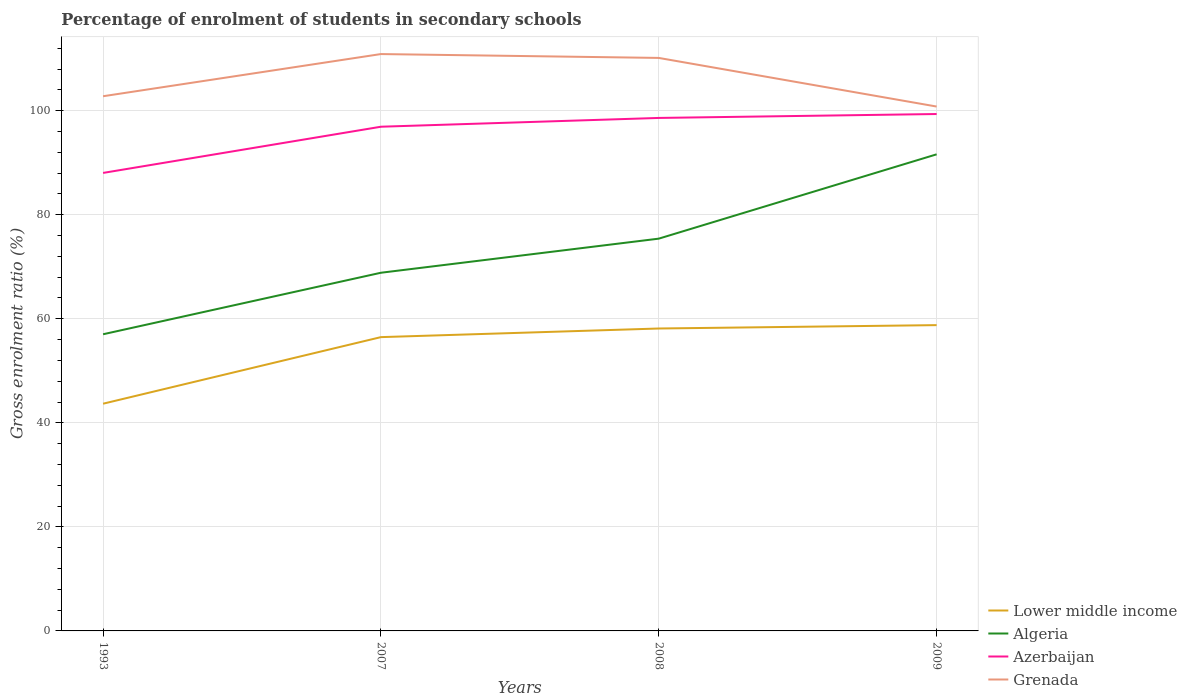Across all years, what is the maximum percentage of students enrolled in secondary schools in Azerbaijan?
Provide a short and direct response. 88.04. What is the total percentage of students enrolled in secondary schools in Algeria in the graph?
Your answer should be compact. -18.38. What is the difference between the highest and the second highest percentage of students enrolled in secondary schools in Azerbaijan?
Provide a succinct answer. 11.32. What is the difference between the highest and the lowest percentage of students enrolled in secondary schools in Algeria?
Provide a short and direct response. 2. How many years are there in the graph?
Your response must be concise. 4. How many legend labels are there?
Your response must be concise. 4. What is the title of the graph?
Ensure brevity in your answer.  Percentage of enrolment of students in secondary schools. What is the label or title of the X-axis?
Your answer should be compact. Years. What is the Gross enrolment ratio (%) in Lower middle income in 1993?
Ensure brevity in your answer.  43.68. What is the Gross enrolment ratio (%) of Algeria in 1993?
Provide a succinct answer. 57.02. What is the Gross enrolment ratio (%) in Azerbaijan in 1993?
Your answer should be very brief. 88.04. What is the Gross enrolment ratio (%) of Grenada in 1993?
Offer a very short reply. 102.78. What is the Gross enrolment ratio (%) in Lower middle income in 2007?
Offer a very short reply. 56.47. What is the Gross enrolment ratio (%) of Algeria in 2007?
Provide a succinct answer. 68.85. What is the Gross enrolment ratio (%) of Azerbaijan in 2007?
Your answer should be compact. 96.92. What is the Gross enrolment ratio (%) in Grenada in 2007?
Give a very brief answer. 110.88. What is the Gross enrolment ratio (%) in Lower middle income in 2008?
Your answer should be compact. 58.13. What is the Gross enrolment ratio (%) of Algeria in 2008?
Offer a very short reply. 75.4. What is the Gross enrolment ratio (%) in Azerbaijan in 2008?
Make the answer very short. 98.61. What is the Gross enrolment ratio (%) in Grenada in 2008?
Offer a terse response. 110.14. What is the Gross enrolment ratio (%) in Lower middle income in 2009?
Provide a short and direct response. 58.78. What is the Gross enrolment ratio (%) of Algeria in 2009?
Your answer should be very brief. 91.61. What is the Gross enrolment ratio (%) in Azerbaijan in 2009?
Give a very brief answer. 99.36. What is the Gross enrolment ratio (%) in Grenada in 2009?
Keep it short and to the point. 100.79. Across all years, what is the maximum Gross enrolment ratio (%) in Lower middle income?
Ensure brevity in your answer.  58.78. Across all years, what is the maximum Gross enrolment ratio (%) of Algeria?
Your answer should be very brief. 91.61. Across all years, what is the maximum Gross enrolment ratio (%) of Azerbaijan?
Your answer should be compact. 99.36. Across all years, what is the maximum Gross enrolment ratio (%) in Grenada?
Offer a terse response. 110.88. Across all years, what is the minimum Gross enrolment ratio (%) in Lower middle income?
Give a very brief answer. 43.68. Across all years, what is the minimum Gross enrolment ratio (%) of Algeria?
Provide a short and direct response. 57.02. Across all years, what is the minimum Gross enrolment ratio (%) of Azerbaijan?
Make the answer very short. 88.04. Across all years, what is the minimum Gross enrolment ratio (%) of Grenada?
Your answer should be very brief. 100.79. What is the total Gross enrolment ratio (%) of Lower middle income in the graph?
Your answer should be very brief. 217.06. What is the total Gross enrolment ratio (%) in Algeria in the graph?
Keep it short and to the point. 292.89. What is the total Gross enrolment ratio (%) of Azerbaijan in the graph?
Offer a terse response. 382.92. What is the total Gross enrolment ratio (%) in Grenada in the graph?
Make the answer very short. 424.6. What is the difference between the Gross enrolment ratio (%) of Lower middle income in 1993 and that in 2007?
Offer a terse response. -12.8. What is the difference between the Gross enrolment ratio (%) of Algeria in 1993 and that in 2007?
Provide a succinct answer. -11.83. What is the difference between the Gross enrolment ratio (%) in Azerbaijan in 1993 and that in 2007?
Keep it short and to the point. -8.88. What is the difference between the Gross enrolment ratio (%) in Grenada in 1993 and that in 2007?
Your response must be concise. -8.11. What is the difference between the Gross enrolment ratio (%) of Lower middle income in 1993 and that in 2008?
Offer a very short reply. -14.46. What is the difference between the Gross enrolment ratio (%) of Algeria in 1993 and that in 2008?
Your answer should be compact. -18.38. What is the difference between the Gross enrolment ratio (%) in Azerbaijan in 1993 and that in 2008?
Your response must be concise. -10.57. What is the difference between the Gross enrolment ratio (%) in Grenada in 1993 and that in 2008?
Your response must be concise. -7.36. What is the difference between the Gross enrolment ratio (%) in Lower middle income in 1993 and that in 2009?
Make the answer very short. -15.1. What is the difference between the Gross enrolment ratio (%) of Algeria in 1993 and that in 2009?
Provide a short and direct response. -34.59. What is the difference between the Gross enrolment ratio (%) of Azerbaijan in 1993 and that in 2009?
Your response must be concise. -11.32. What is the difference between the Gross enrolment ratio (%) in Grenada in 1993 and that in 2009?
Your answer should be very brief. 1.98. What is the difference between the Gross enrolment ratio (%) in Lower middle income in 2007 and that in 2008?
Your response must be concise. -1.66. What is the difference between the Gross enrolment ratio (%) of Algeria in 2007 and that in 2008?
Keep it short and to the point. -6.55. What is the difference between the Gross enrolment ratio (%) of Azerbaijan in 2007 and that in 2008?
Offer a very short reply. -1.69. What is the difference between the Gross enrolment ratio (%) in Grenada in 2007 and that in 2008?
Keep it short and to the point. 0.74. What is the difference between the Gross enrolment ratio (%) in Lower middle income in 2007 and that in 2009?
Offer a terse response. -2.31. What is the difference between the Gross enrolment ratio (%) of Algeria in 2007 and that in 2009?
Your answer should be compact. -22.76. What is the difference between the Gross enrolment ratio (%) of Azerbaijan in 2007 and that in 2009?
Ensure brevity in your answer.  -2.44. What is the difference between the Gross enrolment ratio (%) of Grenada in 2007 and that in 2009?
Your answer should be compact. 10.09. What is the difference between the Gross enrolment ratio (%) of Lower middle income in 2008 and that in 2009?
Provide a succinct answer. -0.65. What is the difference between the Gross enrolment ratio (%) in Algeria in 2008 and that in 2009?
Ensure brevity in your answer.  -16.21. What is the difference between the Gross enrolment ratio (%) in Azerbaijan in 2008 and that in 2009?
Give a very brief answer. -0.75. What is the difference between the Gross enrolment ratio (%) in Grenada in 2008 and that in 2009?
Offer a very short reply. 9.35. What is the difference between the Gross enrolment ratio (%) of Lower middle income in 1993 and the Gross enrolment ratio (%) of Algeria in 2007?
Provide a succinct answer. -25.18. What is the difference between the Gross enrolment ratio (%) of Lower middle income in 1993 and the Gross enrolment ratio (%) of Azerbaijan in 2007?
Provide a short and direct response. -53.24. What is the difference between the Gross enrolment ratio (%) in Lower middle income in 1993 and the Gross enrolment ratio (%) in Grenada in 2007?
Offer a terse response. -67.21. What is the difference between the Gross enrolment ratio (%) in Algeria in 1993 and the Gross enrolment ratio (%) in Azerbaijan in 2007?
Give a very brief answer. -39.89. What is the difference between the Gross enrolment ratio (%) in Algeria in 1993 and the Gross enrolment ratio (%) in Grenada in 2007?
Your answer should be compact. -53.86. What is the difference between the Gross enrolment ratio (%) of Azerbaijan in 1993 and the Gross enrolment ratio (%) of Grenada in 2007?
Provide a short and direct response. -22.85. What is the difference between the Gross enrolment ratio (%) in Lower middle income in 1993 and the Gross enrolment ratio (%) in Algeria in 2008?
Provide a succinct answer. -31.73. What is the difference between the Gross enrolment ratio (%) in Lower middle income in 1993 and the Gross enrolment ratio (%) in Azerbaijan in 2008?
Your response must be concise. -54.93. What is the difference between the Gross enrolment ratio (%) of Lower middle income in 1993 and the Gross enrolment ratio (%) of Grenada in 2008?
Keep it short and to the point. -66.47. What is the difference between the Gross enrolment ratio (%) in Algeria in 1993 and the Gross enrolment ratio (%) in Azerbaijan in 2008?
Provide a succinct answer. -41.58. What is the difference between the Gross enrolment ratio (%) in Algeria in 1993 and the Gross enrolment ratio (%) in Grenada in 2008?
Ensure brevity in your answer.  -53.12. What is the difference between the Gross enrolment ratio (%) in Azerbaijan in 1993 and the Gross enrolment ratio (%) in Grenada in 2008?
Your answer should be very brief. -22.1. What is the difference between the Gross enrolment ratio (%) in Lower middle income in 1993 and the Gross enrolment ratio (%) in Algeria in 2009?
Keep it short and to the point. -47.94. What is the difference between the Gross enrolment ratio (%) of Lower middle income in 1993 and the Gross enrolment ratio (%) of Azerbaijan in 2009?
Keep it short and to the point. -55.68. What is the difference between the Gross enrolment ratio (%) of Lower middle income in 1993 and the Gross enrolment ratio (%) of Grenada in 2009?
Offer a very short reply. -57.12. What is the difference between the Gross enrolment ratio (%) of Algeria in 1993 and the Gross enrolment ratio (%) of Azerbaijan in 2009?
Your response must be concise. -42.33. What is the difference between the Gross enrolment ratio (%) in Algeria in 1993 and the Gross enrolment ratio (%) in Grenada in 2009?
Your response must be concise. -43.77. What is the difference between the Gross enrolment ratio (%) of Azerbaijan in 1993 and the Gross enrolment ratio (%) of Grenada in 2009?
Ensure brevity in your answer.  -12.76. What is the difference between the Gross enrolment ratio (%) of Lower middle income in 2007 and the Gross enrolment ratio (%) of Algeria in 2008?
Offer a terse response. -18.93. What is the difference between the Gross enrolment ratio (%) in Lower middle income in 2007 and the Gross enrolment ratio (%) in Azerbaijan in 2008?
Your answer should be very brief. -42.13. What is the difference between the Gross enrolment ratio (%) in Lower middle income in 2007 and the Gross enrolment ratio (%) in Grenada in 2008?
Provide a short and direct response. -53.67. What is the difference between the Gross enrolment ratio (%) of Algeria in 2007 and the Gross enrolment ratio (%) of Azerbaijan in 2008?
Offer a very short reply. -29.75. What is the difference between the Gross enrolment ratio (%) of Algeria in 2007 and the Gross enrolment ratio (%) of Grenada in 2008?
Provide a short and direct response. -41.29. What is the difference between the Gross enrolment ratio (%) of Azerbaijan in 2007 and the Gross enrolment ratio (%) of Grenada in 2008?
Give a very brief answer. -13.22. What is the difference between the Gross enrolment ratio (%) of Lower middle income in 2007 and the Gross enrolment ratio (%) of Algeria in 2009?
Offer a terse response. -35.14. What is the difference between the Gross enrolment ratio (%) of Lower middle income in 2007 and the Gross enrolment ratio (%) of Azerbaijan in 2009?
Provide a succinct answer. -42.88. What is the difference between the Gross enrolment ratio (%) of Lower middle income in 2007 and the Gross enrolment ratio (%) of Grenada in 2009?
Provide a succinct answer. -44.32. What is the difference between the Gross enrolment ratio (%) of Algeria in 2007 and the Gross enrolment ratio (%) of Azerbaijan in 2009?
Provide a short and direct response. -30.51. What is the difference between the Gross enrolment ratio (%) in Algeria in 2007 and the Gross enrolment ratio (%) in Grenada in 2009?
Ensure brevity in your answer.  -31.94. What is the difference between the Gross enrolment ratio (%) of Azerbaijan in 2007 and the Gross enrolment ratio (%) of Grenada in 2009?
Ensure brevity in your answer.  -3.88. What is the difference between the Gross enrolment ratio (%) in Lower middle income in 2008 and the Gross enrolment ratio (%) in Algeria in 2009?
Ensure brevity in your answer.  -33.48. What is the difference between the Gross enrolment ratio (%) of Lower middle income in 2008 and the Gross enrolment ratio (%) of Azerbaijan in 2009?
Make the answer very short. -41.23. What is the difference between the Gross enrolment ratio (%) in Lower middle income in 2008 and the Gross enrolment ratio (%) in Grenada in 2009?
Provide a succinct answer. -42.66. What is the difference between the Gross enrolment ratio (%) of Algeria in 2008 and the Gross enrolment ratio (%) of Azerbaijan in 2009?
Your answer should be compact. -23.95. What is the difference between the Gross enrolment ratio (%) in Algeria in 2008 and the Gross enrolment ratio (%) in Grenada in 2009?
Provide a short and direct response. -25.39. What is the difference between the Gross enrolment ratio (%) of Azerbaijan in 2008 and the Gross enrolment ratio (%) of Grenada in 2009?
Make the answer very short. -2.19. What is the average Gross enrolment ratio (%) in Lower middle income per year?
Keep it short and to the point. 54.27. What is the average Gross enrolment ratio (%) of Algeria per year?
Your answer should be compact. 73.22. What is the average Gross enrolment ratio (%) of Azerbaijan per year?
Ensure brevity in your answer.  95.73. What is the average Gross enrolment ratio (%) in Grenada per year?
Offer a very short reply. 106.15. In the year 1993, what is the difference between the Gross enrolment ratio (%) in Lower middle income and Gross enrolment ratio (%) in Algeria?
Offer a terse response. -13.35. In the year 1993, what is the difference between the Gross enrolment ratio (%) in Lower middle income and Gross enrolment ratio (%) in Azerbaijan?
Offer a terse response. -44.36. In the year 1993, what is the difference between the Gross enrolment ratio (%) in Lower middle income and Gross enrolment ratio (%) in Grenada?
Give a very brief answer. -59.1. In the year 1993, what is the difference between the Gross enrolment ratio (%) of Algeria and Gross enrolment ratio (%) of Azerbaijan?
Your answer should be very brief. -31.01. In the year 1993, what is the difference between the Gross enrolment ratio (%) of Algeria and Gross enrolment ratio (%) of Grenada?
Offer a very short reply. -45.75. In the year 1993, what is the difference between the Gross enrolment ratio (%) in Azerbaijan and Gross enrolment ratio (%) in Grenada?
Your answer should be compact. -14.74. In the year 2007, what is the difference between the Gross enrolment ratio (%) of Lower middle income and Gross enrolment ratio (%) of Algeria?
Keep it short and to the point. -12.38. In the year 2007, what is the difference between the Gross enrolment ratio (%) of Lower middle income and Gross enrolment ratio (%) of Azerbaijan?
Give a very brief answer. -40.44. In the year 2007, what is the difference between the Gross enrolment ratio (%) of Lower middle income and Gross enrolment ratio (%) of Grenada?
Provide a short and direct response. -54.41. In the year 2007, what is the difference between the Gross enrolment ratio (%) of Algeria and Gross enrolment ratio (%) of Azerbaijan?
Your answer should be compact. -28.07. In the year 2007, what is the difference between the Gross enrolment ratio (%) of Algeria and Gross enrolment ratio (%) of Grenada?
Your answer should be compact. -42.03. In the year 2007, what is the difference between the Gross enrolment ratio (%) in Azerbaijan and Gross enrolment ratio (%) in Grenada?
Your answer should be very brief. -13.97. In the year 2008, what is the difference between the Gross enrolment ratio (%) in Lower middle income and Gross enrolment ratio (%) in Algeria?
Your answer should be very brief. -17.27. In the year 2008, what is the difference between the Gross enrolment ratio (%) in Lower middle income and Gross enrolment ratio (%) in Azerbaijan?
Your answer should be compact. -40.47. In the year 2008, what is the difference between the Gross enrolment ratio (%) of Lower middle income and Gross enrolment ratio (%) of Grenada?
Your response must be concise. -52.01. In the year 2008, what is the difference between the Gross enrolment ratio (%) in Algeria and Gross enrolment ratio (%) in Azerbaijan?
Provide a short and direct response. -23.2. In the year 2008, what is the difference between the Gross enrolment ratio (%) of Algeria and Gross enrolment ratio (%) of Grenada?
Your response must be concise. -34.74. In the year 2008, what is the difference between the Gross enrolment ratio (%) in Azerbaijan and Gross enrolment ratio (%) in Grenada?
Offer a very short reply. -11.54. In the year 2009, what is the difference between the Gross enrolment ratio (%) of Lower middle income and Gross enrolment ratio (%) of Algeria?
Offer a terse response. -32.83. In the year 2009, what is the difference between the Gross enrolment ratio (%) in Lower middle income and Gross enrolment ratio (%) in Azerbaijan?
Make the answer very short. -40.58. In the year 2009, what is the difference between the Gross enrolment ratio (%) in Lower middle income and Gross enrolment ratio (%) in Grenada?
Offer a very short reply. -42.01. In the year 2009, what is the difference between the Gross enrolment ratio (%) in Algeria and Gross enrolment ratio (%) in Azerbaijan?
Make the answer very short. -7.75. In the year 2009, what is the difference between the Gross enrolment ratio (%) in Algeria and Gross enrolment ratio (%) in Grenada?
Provide a succinct answer. -9.18. In the year 2009, what is the difference between the Gross enrolment ratio (%) in Azerbaijan and Gross enrolment ratio (%) in Grenada?
Your answer should be compact. -1.44. What is the ratio of the Gross enrolment ratio (%) in Lower middle income in 1993 to that in 2007?
Provide a short and direct response. 0.77. What is the ratio of the Gross enrolment ratio (%) of Algeria in 1993 to that in 2007?
Offer a terse response. 0.83. What is the ratio of the Gross enrolment ratio (%) of Azerbaijan in 1993 to that in 2007?
Your answer should be very brief. 0.91. What is the ratio of the Gross enrolment ratio (%) in Grenada in 1993 to that in 2007?
Offer a terse response. 0.93. What is the ratio of the Gross enrolment ratio (%) in Lower middle income in 1993 to that in 2008?
Provide a succinct answer. 0.75. What is the ratio of the Gross enrolment ratio (%) of Algeria in 1993 to that in 2008?
Your answer should be compact. 0.76. What is the ratio of the Gross enrolment ratio (%) of Azerbaijan in 1993 to that in 2008?
Your response must be concise. 0.89. What is the ratio of the Gross enrolment ratio (%) in Grenada in 1993 to that in 2008?
Your response must be concise. 0.93. What is the ratio of the Gross enrolment ratio (%) in Lower middle income in 1993 to that in 2009?
Offer a terse response. 0.74. What is the ratio of the Gross enrolment ratio (%) of Algeria in 1993 to that in 2009?
Your answer should be compact. 0.62. What is the ratio of the Gross enrolment ratio (%) in Azerbaijan in 1993 to that in 2009?
Your answer should be very brief. 0.89. What is the ratio of the Gross enrolment ratio (%) in Grenada in 1993 to that in 2009?
Give a very brief answer. 1.02. What is the ratio of the Gross enrolment ratio (%) of Lower middle income in 2007 to that in 2008?
Your answer should be compact. 0.97. What is the ratio of the Gross enrolment ratio (%) of Algeria in 2007 to that in 2008?
Make the answer very short. 0.91. What is the ratio of the Gross enrolment ratio (%) of Azerbaijan in 2007 to that in 2008?
Provide a short and direct response. 0.98. What is the ratio of the Gross enrolment ratio (%) in Grenada in 2007 to that in 2008?
Your answer should be very brief. 1.01. What is the ratio of the Gross enrolment ratio (%) of Lower middle income in 2007 to that in 2009?
Your answer should be very brief. 0.96. What is the ratio of the Gross enrolment ratio (%) of Algeria in 2007 to that in 2009?
Offer a very short reply. 0.75. What is the ratio of the Gross enrolment ratio (%) of Azerbaijan in 2007 to that in 2009?
Make the answer very short. 0.98. What is the ratio of the Gross enrolment ratio (%) of Grenada in 2007 to that in 2009?
Ensure brevity in your answer.  1.1. What is the ratio of the Gross enrolment ratio (%) of Algeria in 2008 to that in 2009?
Keep it short and to the point. 0.82. What is the ratio of the Gross enrolment ratio (%) in Grenada in 2008 to that in 2009?
Your response must be concise. 1.09. What is the difference between the highest and the second highest Gross enrolment ratio (%) in Lower middle income?
Your answer should be compact. 0.65. What is the difference between the highest and the second highest Gross enrolment ratio (%) of Algeria?
Offer a terse response. 16.21. What is the difference between the highest and the second highest Gross enrolment ratio (%) of Azerbaijan?
Provide a succinct answer. 0.75. What is the difference between the highest and the second highest Gross enrolment ratio (%) in Grenada?
Make the answer very short. 0.74. What is the difference between the highest and the lowest Gross enrolment ratio (%) of Lower middle income?
Your response must be concise. 15.1. What is the difference between the highest and the lowest Gross enrolment ratio (%) of Algeria?
Provide a succinct answer. 34.59. What is the difference between the highest and the lowest Gross enrolment ratio (%) of Azerbaijan?
Provide a short and direct response. 11.32. What is the difference between the highest and the lowest Gross enrolment ratio (%) of Grenada?
Your answer should be compact. 10.09. 